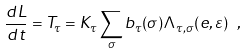<formula> <loc_0><loc_0><loc_500><loc_500>\frac { d L } { d t } = T _ { \tau } = K _ { \tau } \sum _ { \sigma } b _ { \tau } ( \sigma ) \Lambda _ { \tau , \sigma } ( e , \varepsilon ) \ ,</formula> 